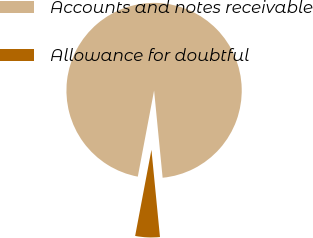Convert chart to OTSL. <chart><loc_0><loc_0><loc_500><loc_500><pie_chart><fcel>Accounts and notes receivable<fcel>Allowance for doubtful<nl><fcel>95.47%<fcel>4.53%<nl></chart> 